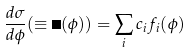<formula> <loc_0><loc_0><loc_500><loc_500>\frac { d \sigma } { d \phi } ( \equiv \mathit \Sigma ( \phi ) ) = \sum _ { i } c _ { i } f _ { i } ( \phi )</formula> 